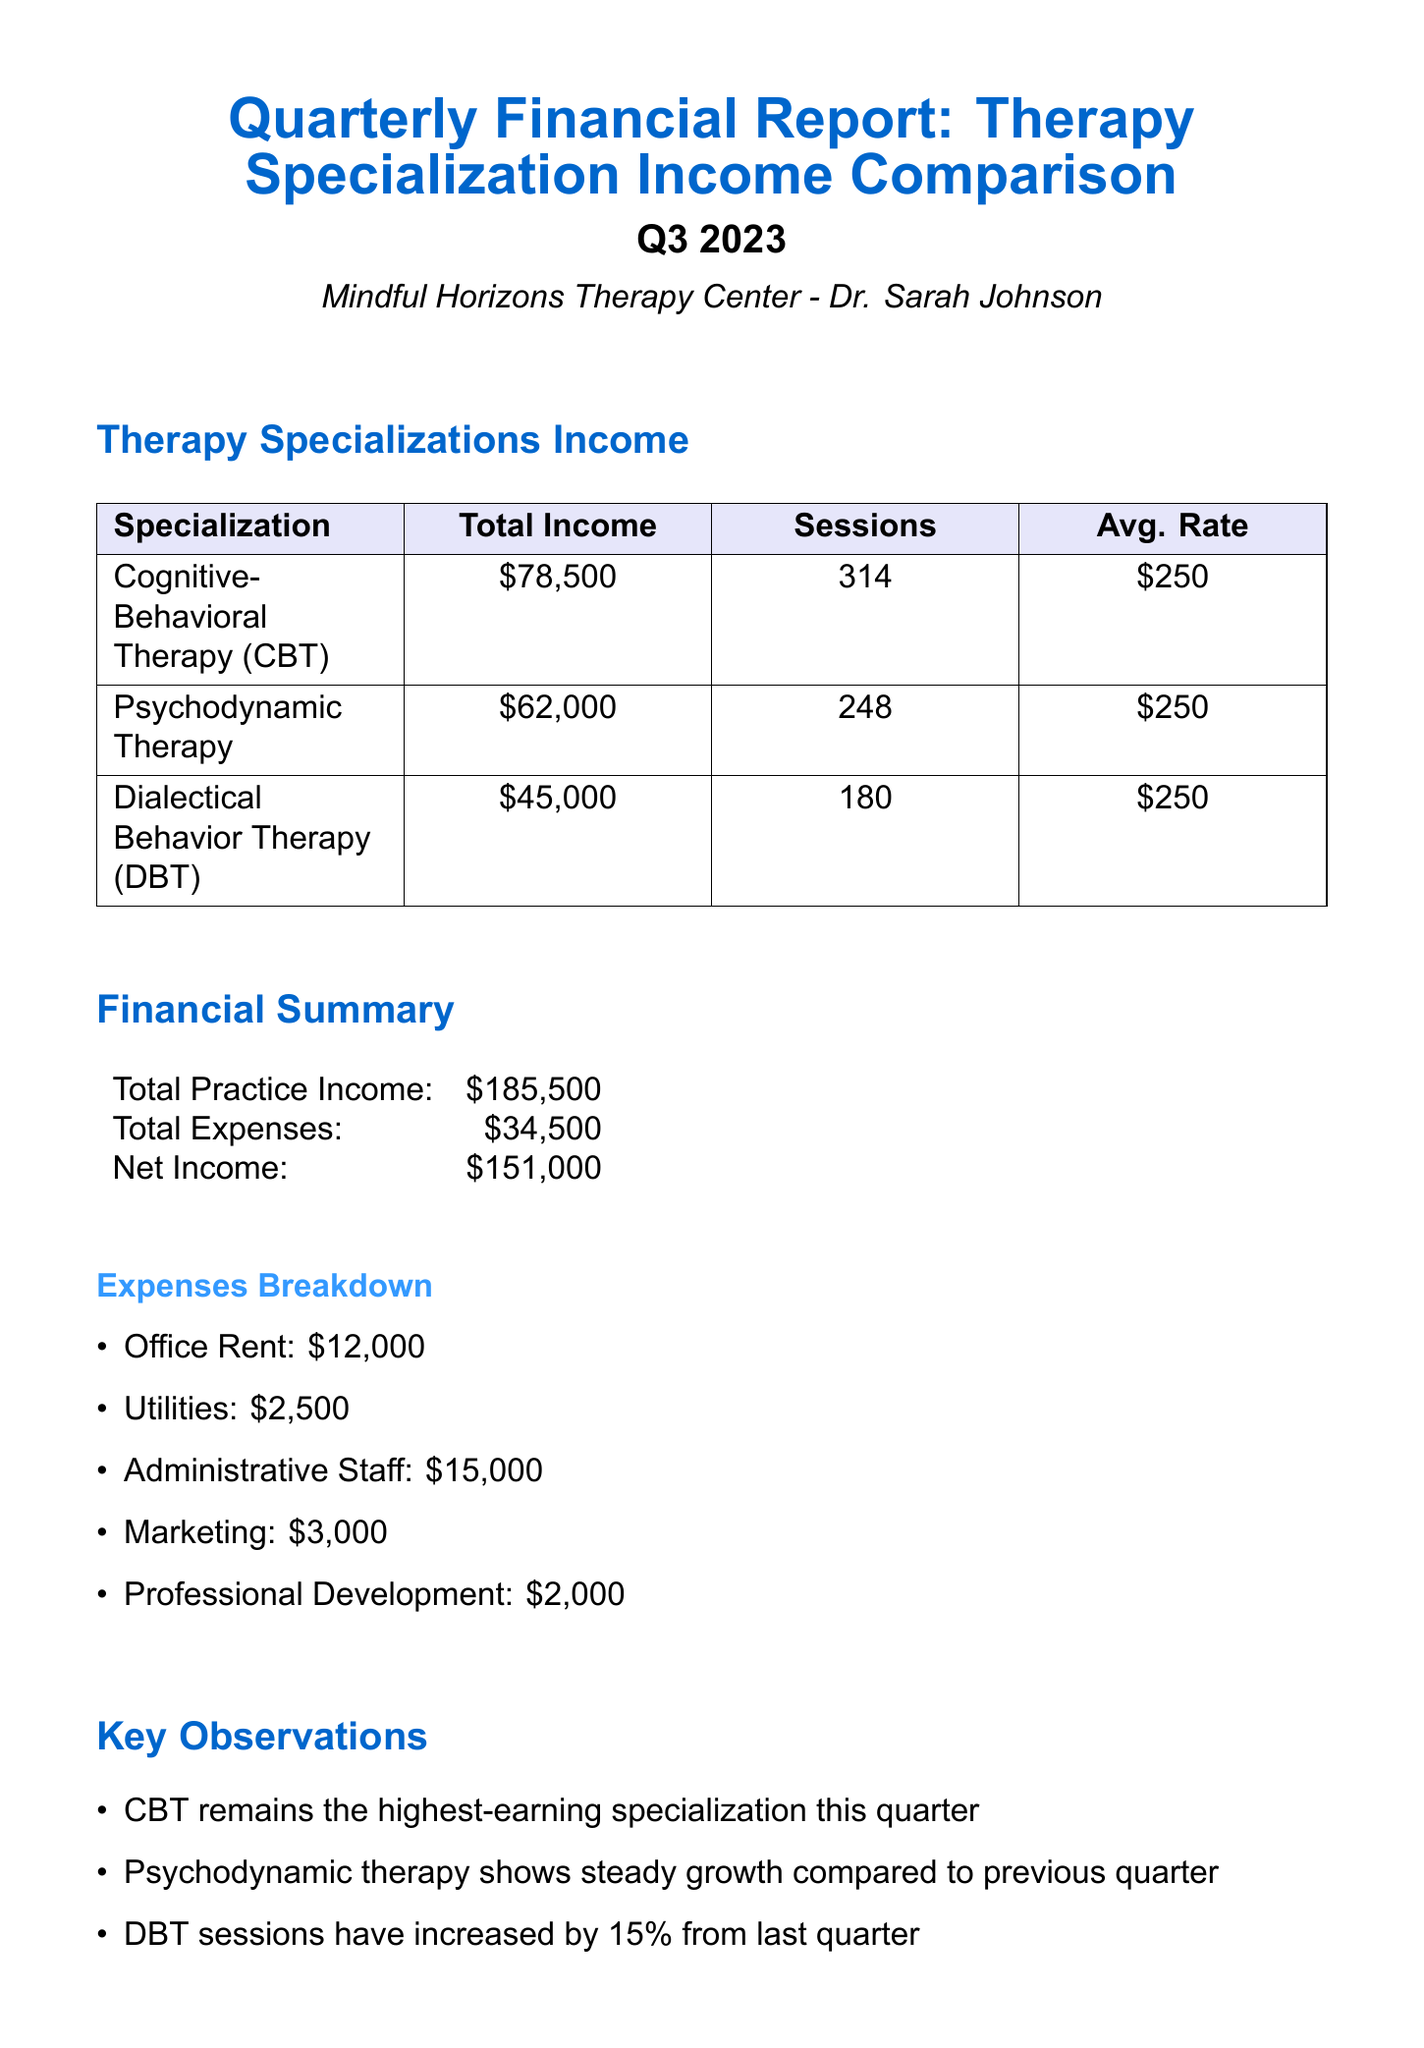what is the total income from Cognitive-Behavioral Therapy? The total income for Cognitive-Behavioral Therapy is mentioned specifically in the document.
Answer: $78,500 how many sessions were conducted for Psychodynamic Therapy? The number of sessions for Psychodynamic Therapy is clearly stated in the therapy specializations section of the report.
Answer: 248 what is the average session rate for Dialectical Behavior Therapy? The average session rate is uniform across all therapy specializations and is provided in the income comparison section.
Answer: $250 what is the total practice income? The total practice income is explicitly listed under the financial summary section of the document.
Answer: $185,500 how much did the practice spend on office rent? The detailed breakdown of expenses includes the cost allocated for office rent.
Answer: $12,000 which therapy specialization shows steady growth compared to the previous quarter? A specific observation in the report mentions the growth trend of a particular specialization.
Answer: Psychodynamic therapy how much did the practice earn from Dialectical Behavior Therapy? The document provides total income specifically for Dialectical Behavior Therapy under the income comparison section.
Answer: $45,000 what is one of the future recommendations regarding CBT services? Future recommendations specifically suggest actions concerning the expansion of services associated with CBT.
Answer: Consider expanding CBT services to meet growing demand what was the total expense for administrative staff? The specific cost for administrative staff is detailed in the expenses breakdown section of the document.
Answer: $15,000 